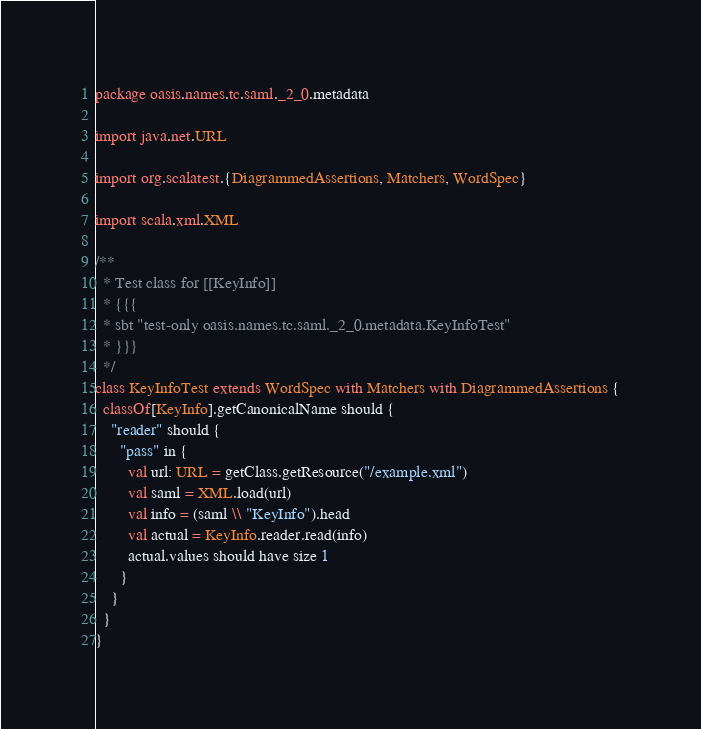<code> <loc_0><loc_0><loc_500><loc_500><_Scala_>package oasis.names.tc.saml._2_0.metadata

import java.net.URL

import org.scalatest.{DiagrammedAssertions, Matchers, WordSpec}

import scala.xml.XML

/**
  * Test class for [[KeyInfo]]
  * {{{
  * sbt "test-only oasis.names.tc.saml._2_0.metadata.KeyInfoTest"
  * }}}
  */
class KeyInfoTest extends WordSpec with Matchers with DiagrammedAssertions {
  classOf[KeyInfo].getCanonicalName should {
    "reader" should {
      "pass" in {
        val url: URL = getClass.getResource("/example.xml")
        val saml = XML.load(url)
        val info = (saml \\ "KeyInfo").head
        val actual = KeyInfo.reader.read(info)
        actual.values should have size 1
      }
    }
  }
}
</code> 